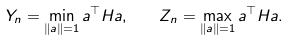Convert formula to latex. <formula><loc_0><loc_0><loc_500><loc_500>Y _ { n } = \min _ { \| a \| = 1 } a ^ { \top } H a , \quad Z _ { n } = \max _ { \| a \| = 1 } a ^ { \top } H a .</formula> 